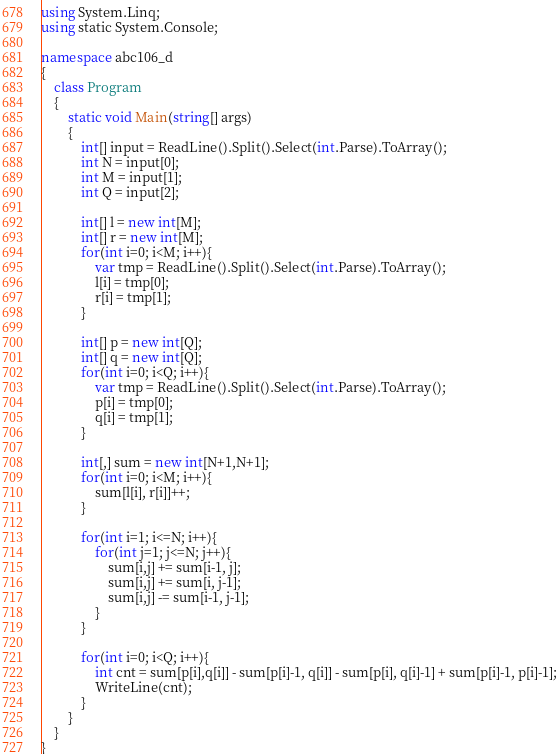Convert code to text. <code><loc_0><loc_0><loc_500><loc_500><_C#_>using System.Linq;
using static System.Console;

namespace abc106_d
{
    class Program
    {
        static void Main(string[] args)
        {
            int[] input = ReadLine().Split().Select(int.Parse).ToArray();
            int N = input[0];
            int M = input[1];
            int Q = input[2];

            int[] l = new int[M];
            int[] r = new int[M];
            for(int i=0; i<M; i++){
                var tmp = ReadLine().Split().Select(int.Parse).ToArray();
                l[i] = tmp[0];
                r[i] = tmp[1];
            }

            int[] p = new int[Q];
            int[] q = new int[Q];
            for(int i=0; i<Q; i++){
                var tmp = ReadLine().Split().Select(int.Parse).ToArray();
                p[i] = tmp[0];
                q[i] = tmp[1];
            }

            int[,] sum = new int[N+1,N+1];
            for(int i=0; i<M; i++){
                sum[l[i], r[i]]++;
            }

            for(int i=1; i<=N; i++){
                for(int j=1; j<=N; j++){
                    sum[i,j] += sum[i-1, j];
                    sum[i,j] += sum[i, j-1];
                    sum[i,j] -= sum[i-1, j-1];
                }
            }

            for(int i=0; i<Q; i++){
                int cnt = sum[p[i],q[i]] - sum[p[i]-1, q[i]] - sum[p[i], q[i]-1] + sum[p[i]-1, p[i]-1];
                WriteLine(cnt);
            }
        }
    }
}</code> 